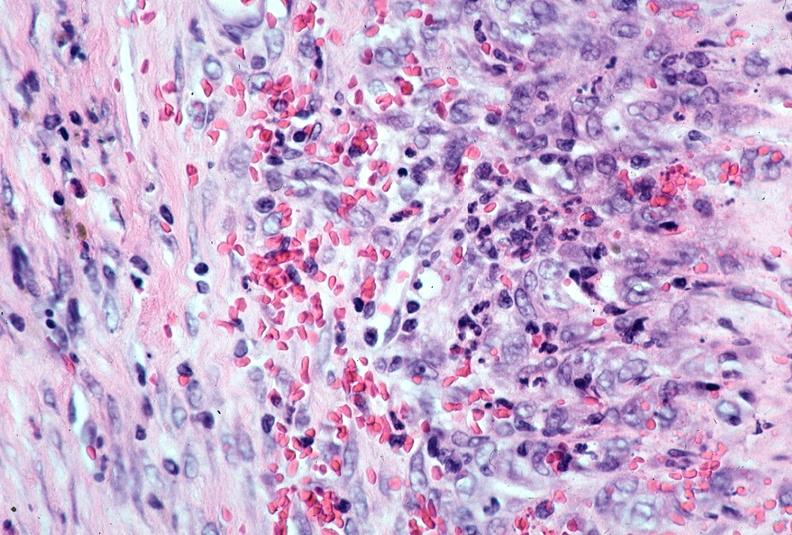what is present?
Answer the question using a single word or phrase. Vasculature 